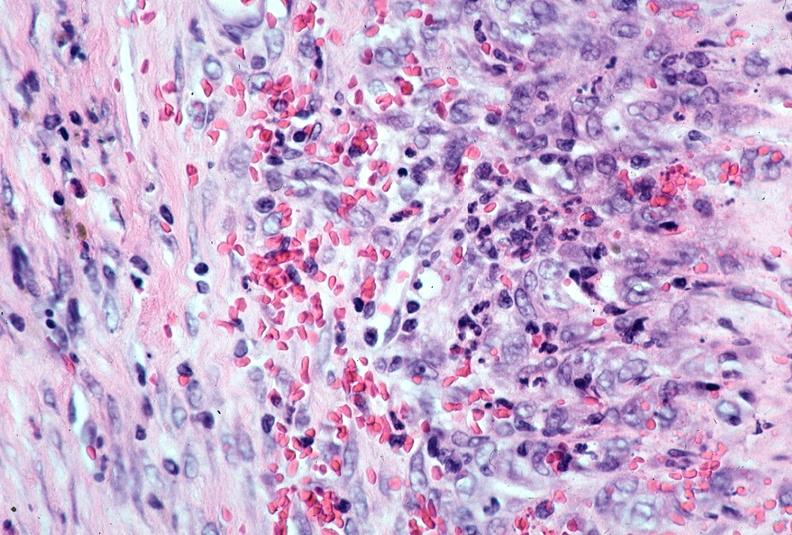what is present?
Answer the question using a single word or phrase. Vasculature 